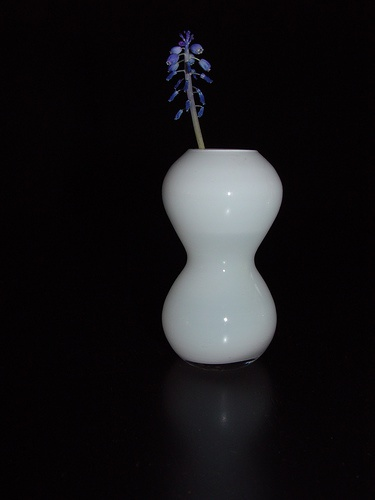Describe the objects in this image and their specific colors. I can see a vase in black, darkgray, gray, and lightgray tones in this image. 